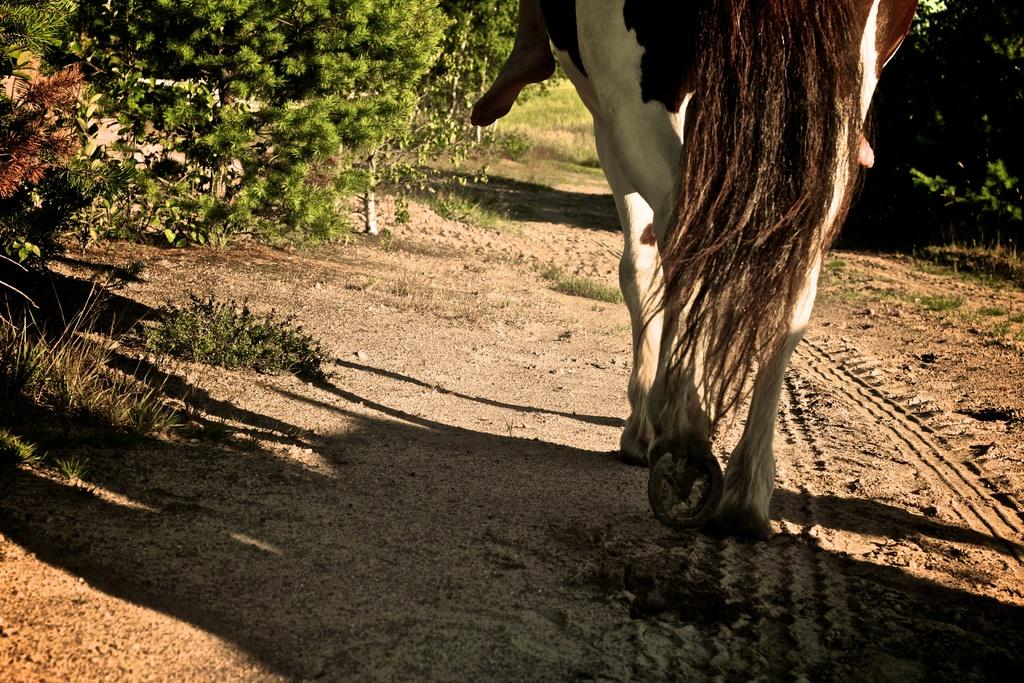What type of animal is in the image? There is a horse in the image. Can you see any part of a person in the image? Yes, a person's leg is visible in the image. What type of terrain is in the image? There is soil and grass in the image. Are there any plants in the image? Yes, there are plants in the image. What type of beam is holding up the horse in the image? There is no beam present in the image; the horse is standing on the ground. 